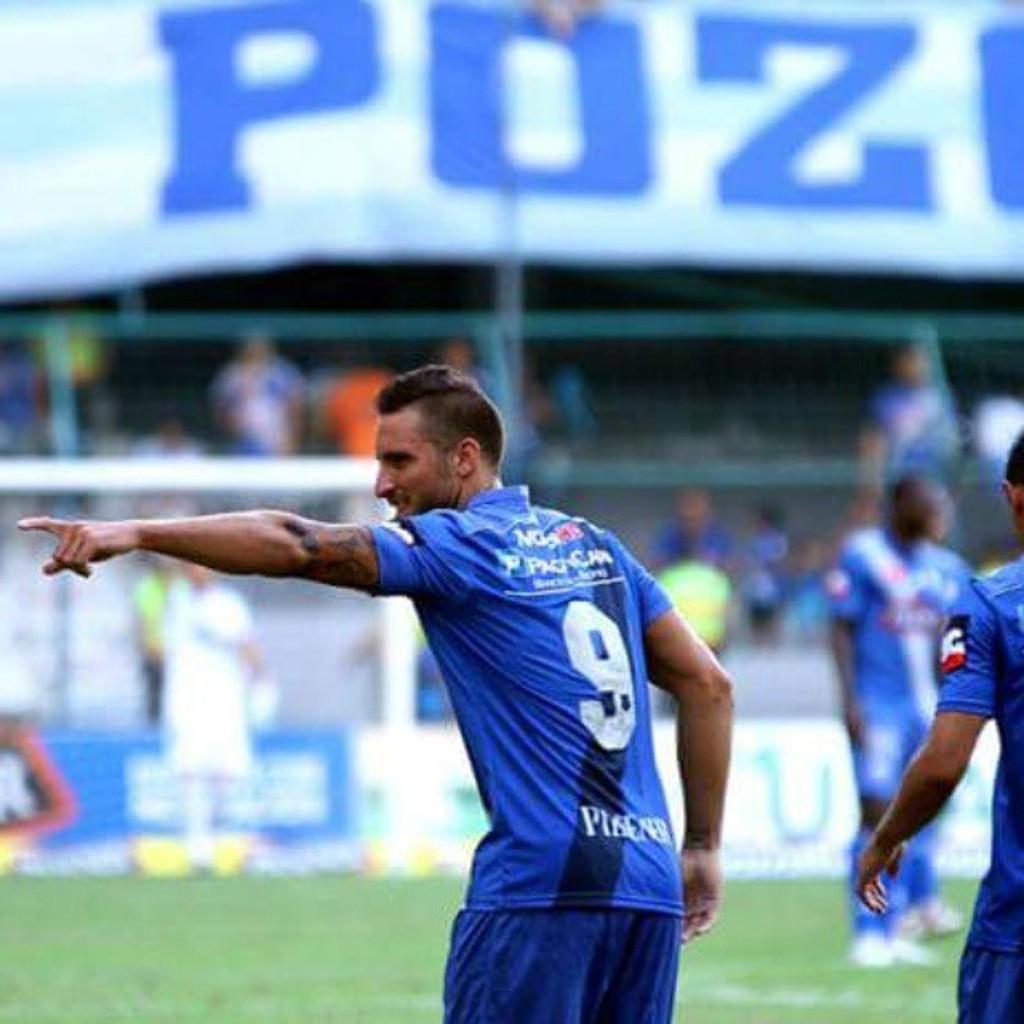What number is on the player's jersey?
Provide a short and direct response. 9. What's the first letter on the banner?
Your answer should be compact. P. 